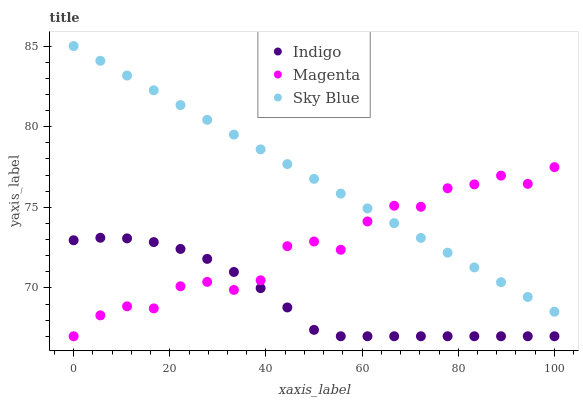Does Indigo have the minimum area under the curve?
Answer yes or no. Yes. Does Sky Blue have the maximum area under the curve?
Answer yes or no. Yes. Does Magenta have the minimum area under the curve?
Answer yes or no. No. Does Magenta have the maximum area under the curve?
Answer yes or no. No. Is Sky Blue the smoothest?
Answer yes or no. Yes. Is Magenta the roughest?
Answer yes or no. Yes. Is Indigo the smoothest?
Answer yes or no. No. Is Indigo the roughest?
Answer yes or no. No. Does Magenta have the lowest value?
Answer yes or no. Yes. Does Sky Blue have the highest value?
Answer yes or no. Yes. Does Magenta have the highest value?
Answer yes or no. No. Is Indigo less than Sky Blue?
Answer yes or no. Yes. Is Sky Blue greater than Indigo?
Answer yes or no. Yes. Does Indigo intersect Magenta?
Answer yes or no. Yes. Is Indigo less than Magenta?
Answer yes or no. No. Is Indigo greater than Magenta?
Answer yes or no. No. Does Indigo intersect Sky Blue?
Answer yes or no. No. 